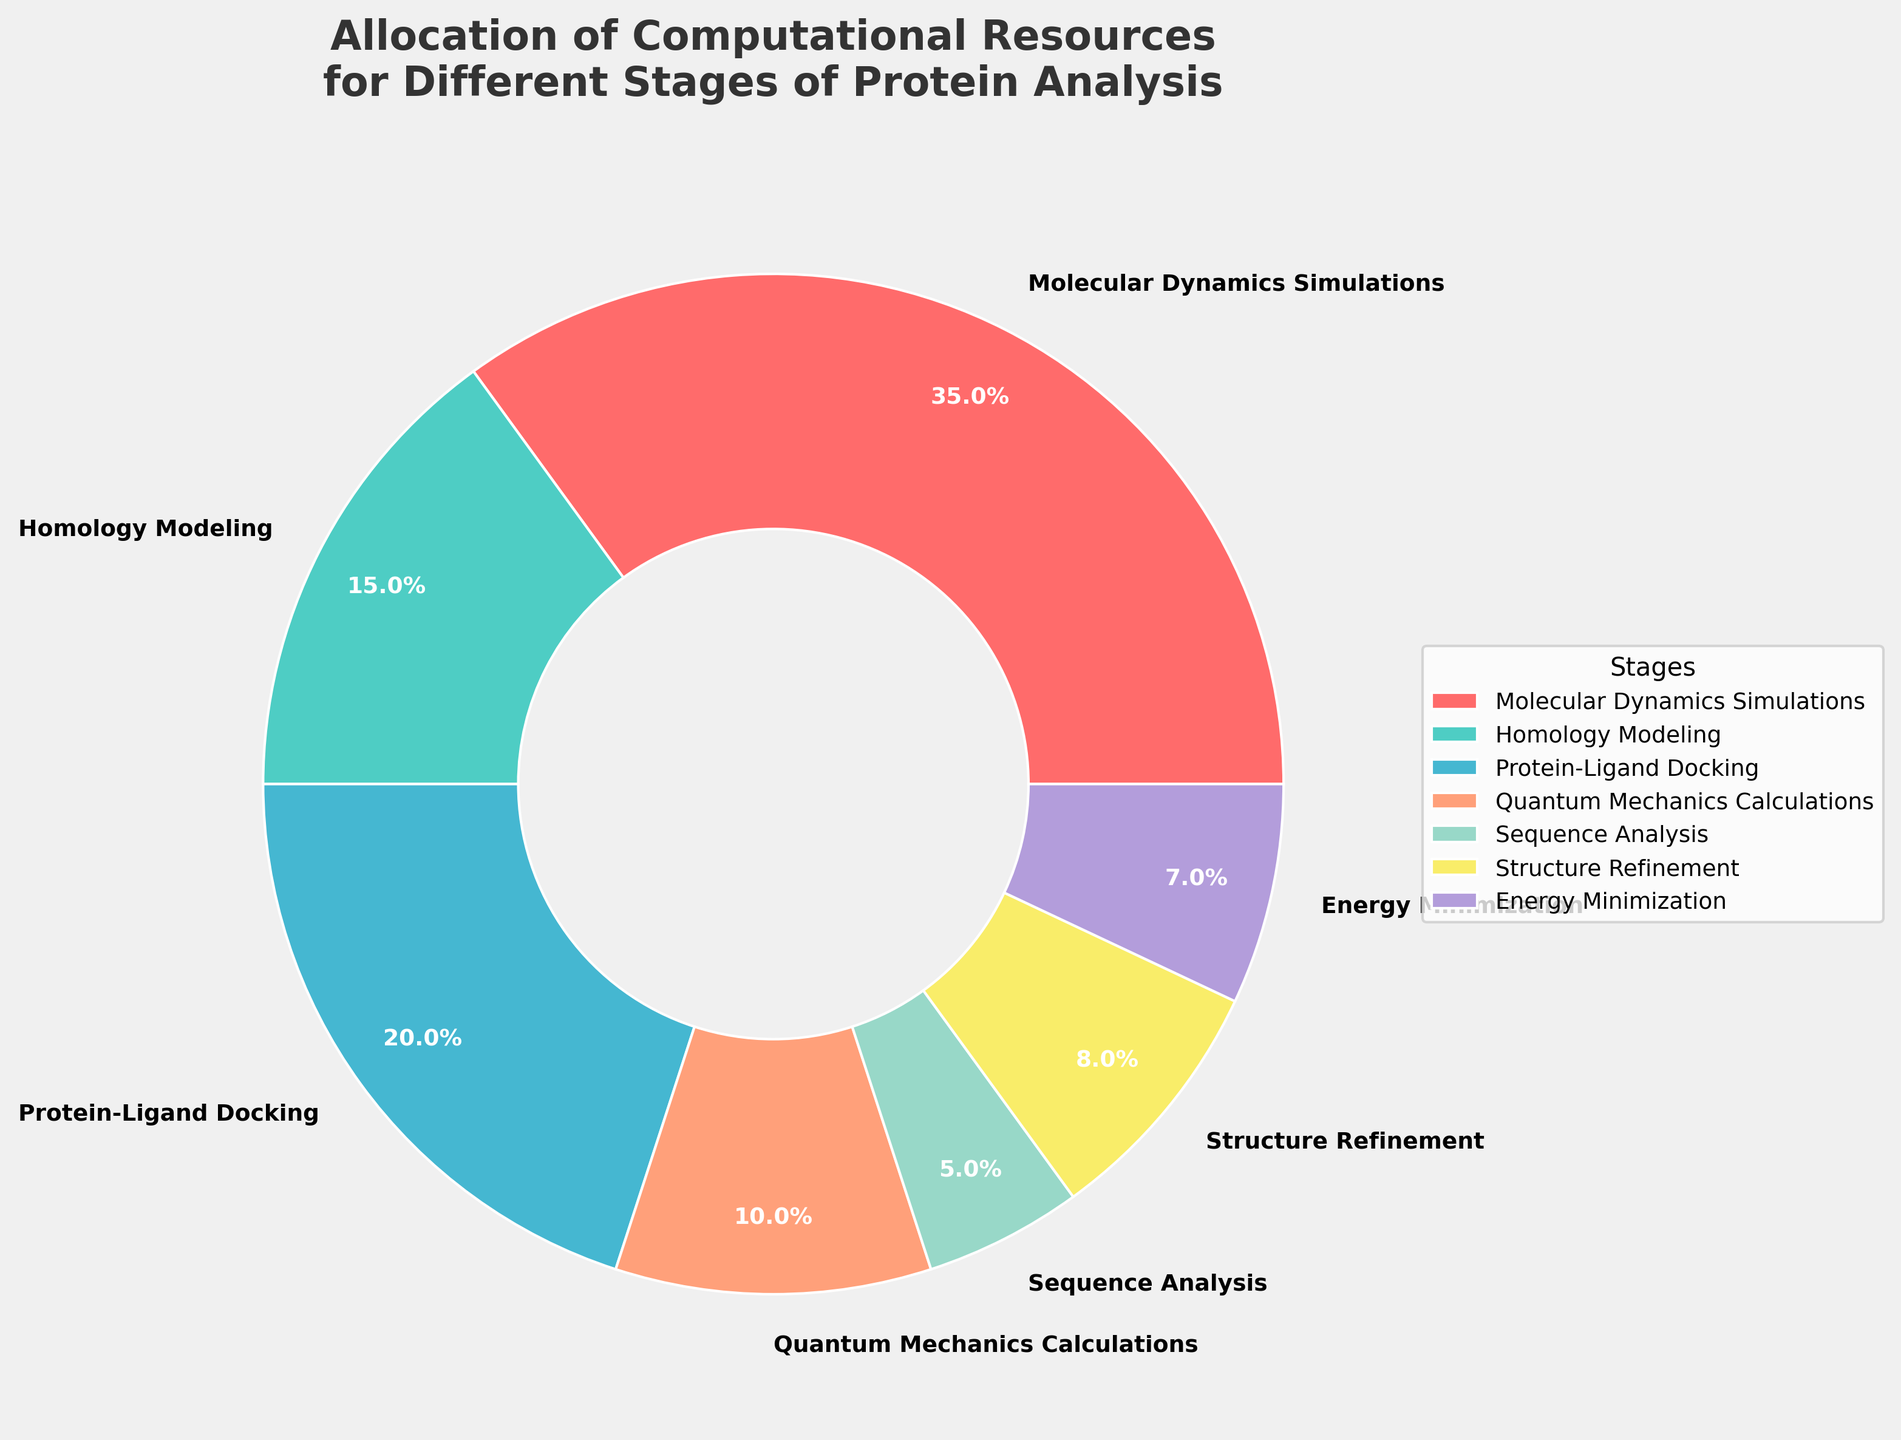What stage uses the highest percentage of computational resources? Molecular Dynamics Simulations uses 35% of the computational resources, which is the highest percentage among all the stages in the chart.
Answer: Molecular Dynamics Simulations Which stage uses less resources: Sequence Analysis or Energy Minimization? Sequence Analysis uses 5% of the computational resources, while Energy Minimization uses 7%. Therefore, Sequence Analysis uses less resources than Energy Minimization.
Answer: Sequence Analysis What is the total percentage of resources allocated to both Protein-Ligand Docking and Structure Refinement? Protein-Ligand Docking uses 20% and Structure Refinement uses 8%. The total percentage for these two stages is 20% + 8% = 28%.
Answer: 28% How much more resources does Molecular Dynamics Simulations use compared to Quantum Mechanics Calculations? Molecular Dynamics Simulations use 35% and Quantum Mechanics Calculations use 10%. The difference is 35% - 10% = 25%.
Answer: 25% Which stages combined use more than 50% of the computational resources? Molecular Dynamics Simulations (35%), Protein-Ligand Docking (20%) combined sum up to 55%, which is more than 50%.
Answer: Molecular Dynamics Simulations and Protein-Ligand Docking What is the difference in resource allocation between Homology Modeling and Sequence Analysis? Homology Modeling uses 15% and Sequence Analysis uses 5%. The difference is 15% - 5% = 10%.
Answer: 10% How many stages use less than 10% of the computational resources each? Sequence Analysis (5%), Structure Refinement (8%), and Energy Minimization (7%) each use less than 10% of the resources. In total, there are 3 stages.
Answer: 3 stages Which stage uses resources closest to 20%? Protein-Ligand Docking uses 20% of the computational resources, which is exactly 20%.
Answer: Protein-Ligand Docking 